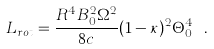Convert formula to latex. <formula><loc_0><loc_0><loc_500><loc_500>L _ { r o t } = \frac { R ^ { 4 } B _ { 0 } ^ { 2 } \Omega ^ { 2 } } { 8 c } ( 1 - \kappa ) ^ { 2 } \Theta _ { 0 } ^ { 4 } \ .</formula> 